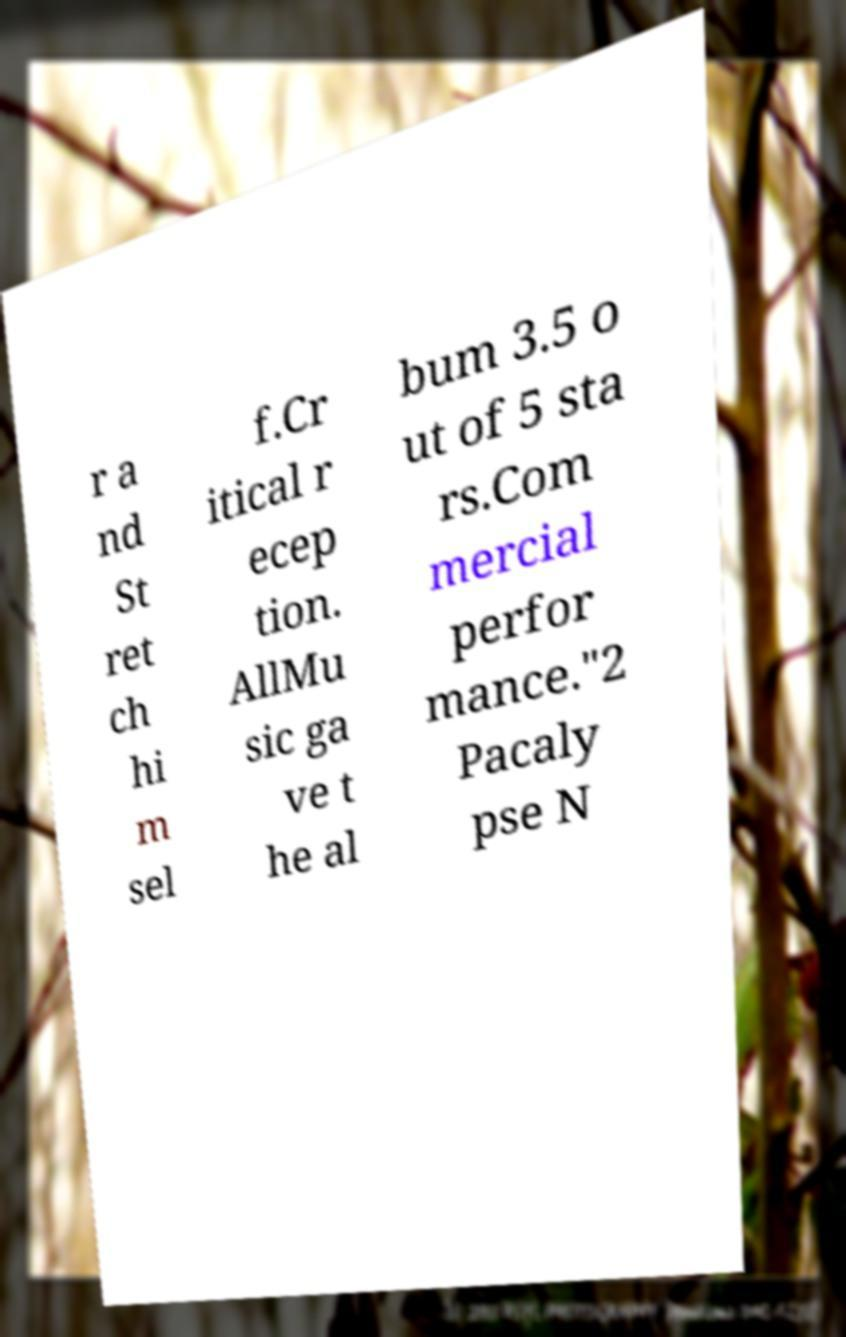For documentation purposes, I need the text within this image transcribed. Could you provide that? r a nd St ret ch hi m sel f.Cr itical r ecep tion. AllMu sic ga ve t he al bum 3.5 o ut of 5 sta rs.Com mercial perfor mance."2 Pacaly pse N 